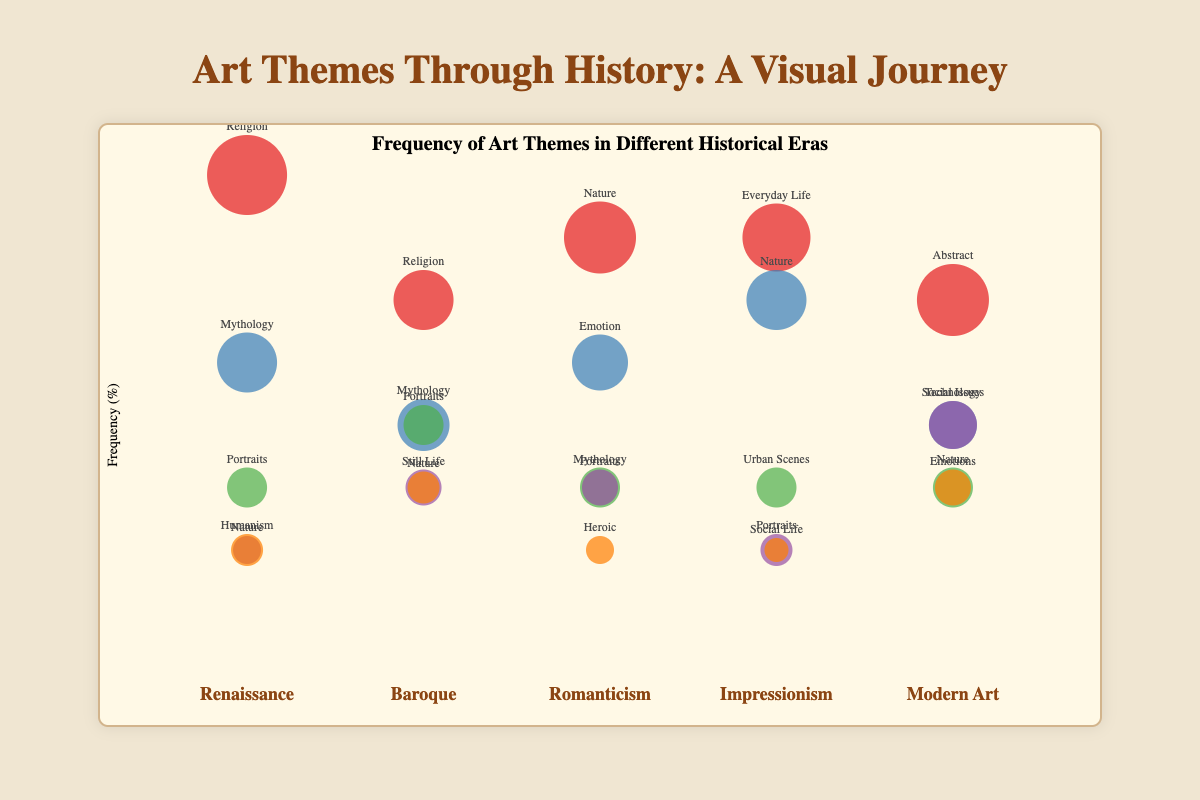What is the most frequent theme in the Renaissance era? Look at the circles under the Renaissance label and find the one with the highest vertical placement. "Religion" has the highest frequency at 40%.
Answer: Religion Which era has the highest frequency for the theme "Nature"? Compare the height of "Nature" circles across all eras. The Romanticism era has the highest frequency for "Nature" at 35%.
Answer: Romanticism How many different themes are shown in the Baroque era? Count the number of circles under the Baroque label. There are 5 circles representing different themes.
Answer: 5 What is the total frequency of all themes in the Impressionism era? Add up the frequencies of all circles under the Impressionism label: 35% (Everyday Life) + 30% (Nature) + 15% (Urban Scenes) + 10% (Portraits) + 10% (Social Life) = 100%.
Answer: 100% Which era has the larger size for the theme "Mythology", Renaissance or Baroque? Compare the sizes of the "Mythology" circles in the Renaissance (size 15) and Baroque (size 13) eras. The Renaissance era has a larger size for "Mythology".
Answer: Renaissance What is the average frequency of the themes in the Modern Art era? Sum the frequencies of circles in the Modern Art era: 30% (Abstract) + 20% (Social Issues) + 15% (Nature) + 20% (Technology) + 15% (Emotions) = 100%. The average is 100/5 = 20%.
Answer: 20% Which two themes have equal frequencies in the Romanticism era? Looking at the Romanticism era, "Mythology" and "Portraits" both have a frequency of 15%.
Answer: Mythology and Portraits Is the frequency of the theme "Portraits" in Renaissance greater than the frequency of the theme "Portraits" in Impressionism? Compare the "Portraits" frequencies in Renaissance (15%) and Impressionism (10%). The frequency in Renaissance is greater.
Answer: Yes What theme has the smallest size in the Modern Art era? Identify the circle with the smallest size in Modern Art, which is "Social Issues" and "Technology" both with size 12. Since both are same, we can mention either one.
Answer: Social Issues or Technology 